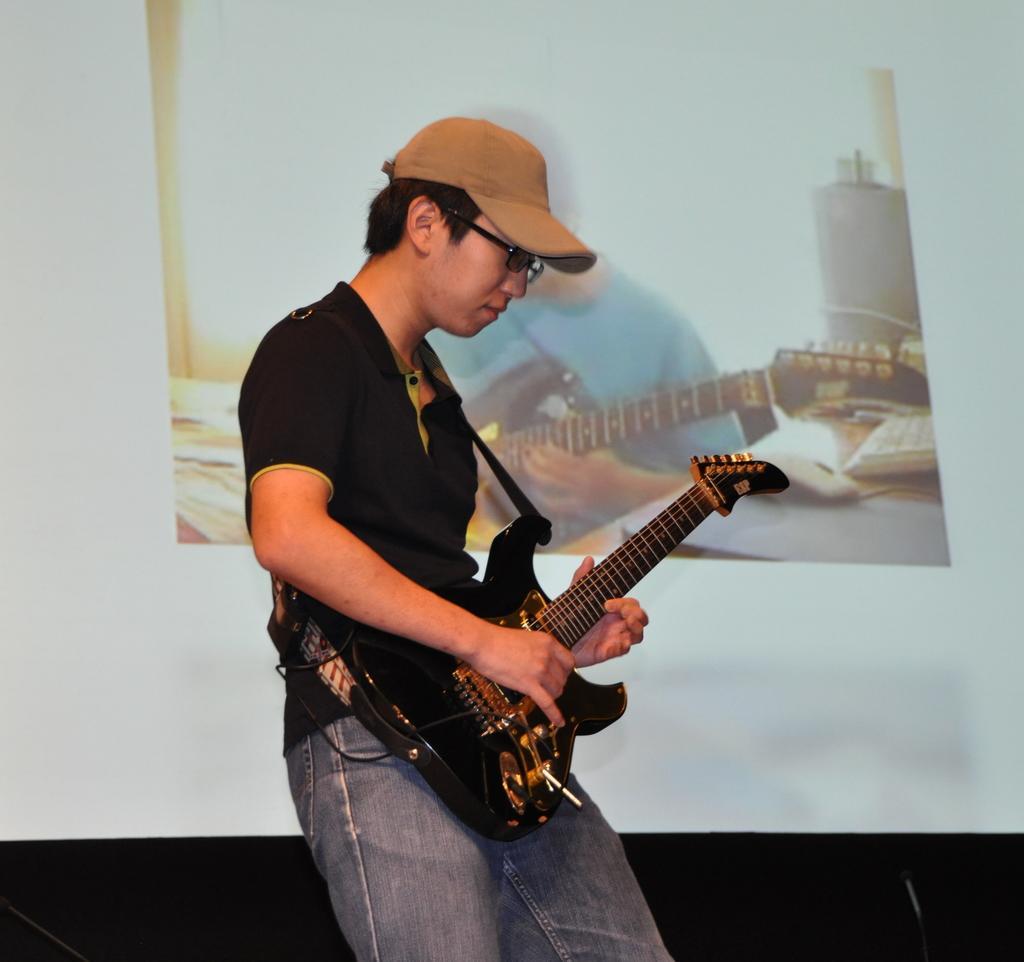Please provide a concise description of this image. This man is standing and playing guitar. On wall there is a poster. This man wore cap and goggles. 